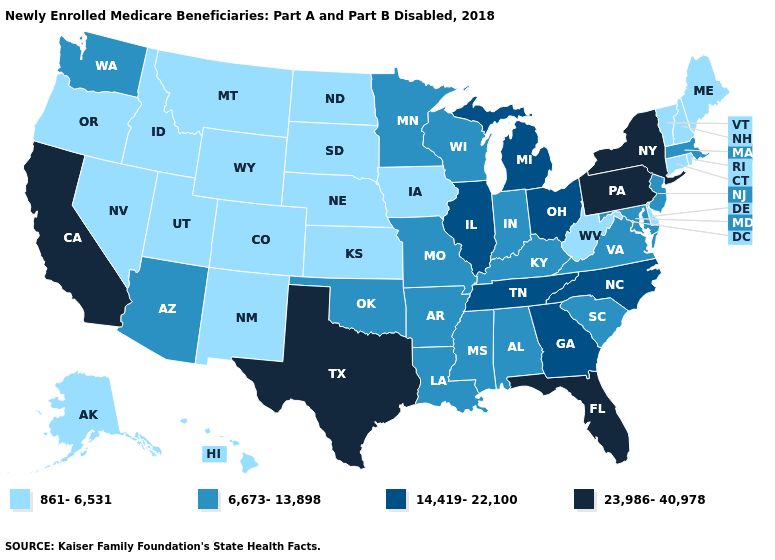What is the value of Colorado?
Quick response, please. 861-6,531. Does Texas have the highest value in the USA?
Answer briefly. Yes. Does the map have missing data?
Give a very brief answer. No. Does the first symbol in the legend represent the smallest category?
Concise answer only. Yes. Is the legend a continuous bar?
Quick response, please. No. Does West Virginia have the lowest value in the South?
Short answer required. Yes. What is the value of Hawaii?
Answer briefly. 861-6,531. Is the legend a continuous bar?
Write a very short answer. No. What is the value of Michigan?
Concise answer only. 14,419-22,100. What is the value of Wisconsin?
Short answer required. 6,673-13,898. Does Minnesota have the lowest value in the USA?
Answer briefly. No. Does Kansas have the lowest value in the USA?
Concise answer only. Yes. Does Florida have a lower value than New Jersey?
Give a very brief answer. No. Name the states that have a value in the range 6,673-13,898?
Give a very brief answer. Alabama, Arizona, Arkansas, Indiana, Kentucky, Louisiana, Maryland, Massachusetts, Minnesota, Mississippi, Missouri, New Jersey, Oklahoma, South Carolina, Virginia, Washington, Wisconsin. Name the states that have a value in the range 861-6,531?
Write a very short answer. Alaska, Colorado, Connecticut, Delaware, Hawaii, Idaho, Iowa, Kansas, Maine, Montana, Nebraska, Nevada, New Hampshire, New Mexico, North Dakota, Oregon, Rhode Island, South Dakota, Utah, Vermont, West Virginia, Wyoming. 